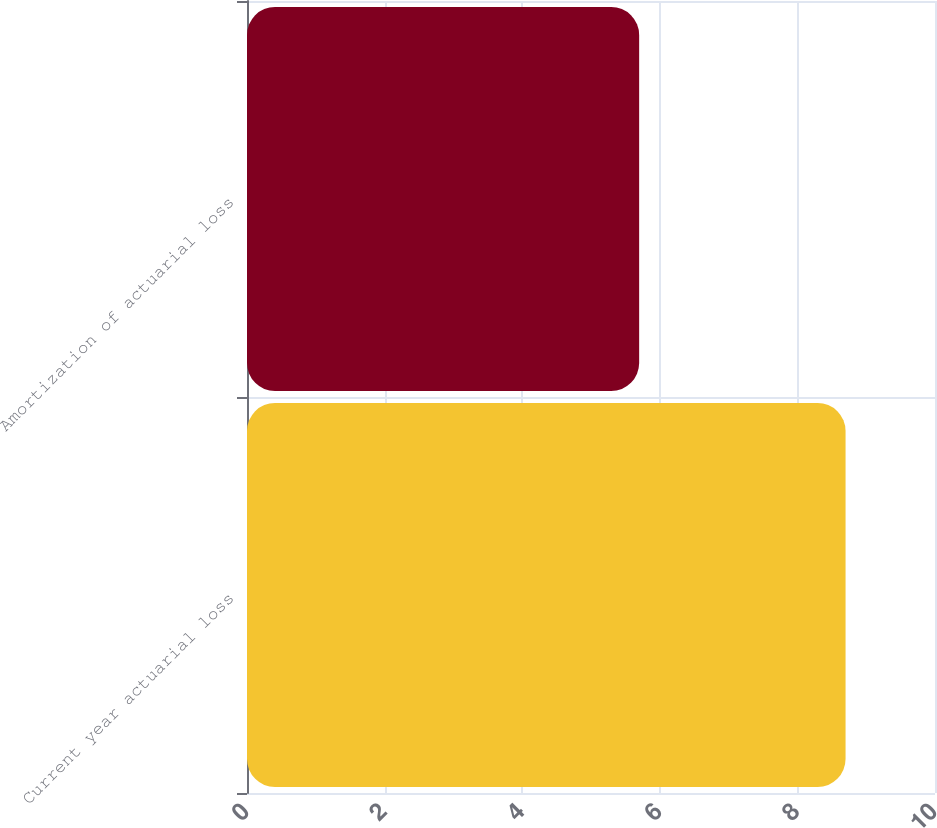Convert chart to OTSL. <chart><loc_0><loc_0><loc_500><loc_500><bar_chart><fcel>Current year actuarial loss<fcel>Amortization of actuarial loss<nl><fcel>8.7<fcel>5.7<nl></chart> 